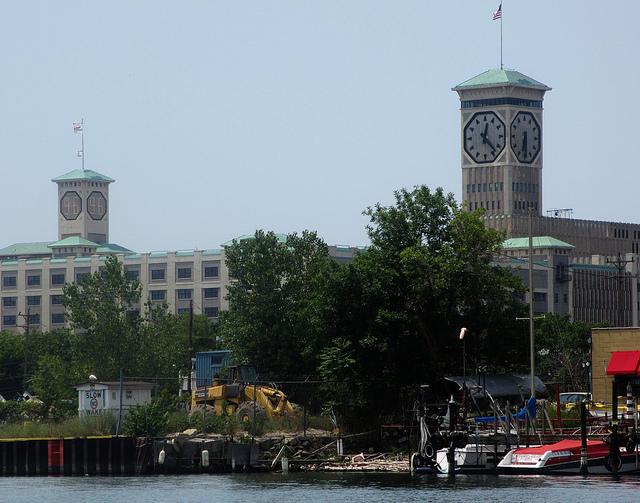What is the clock for?
Short answer required. Telling time. Is the time visible?
Keep it brief. Yes. Is this place in the USA?
Write a very short answer. Yes. What country is this?
Short answer required. Usa. Do people live in this structure?
Be succinct. No. What color is the building that has a clock on top of it?
Short answer required. Tan. 